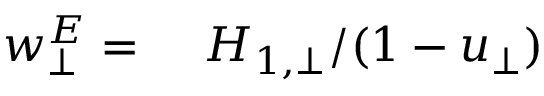<formula> <loc_0><loc_0><loc_500><loc_500>\begin{array} { r l } { w _ { \bot } ^ { E } = } & \ H _ { 1 , \bot } / ( 1 - u _ { \bot } ) } \end{array}</formula> 